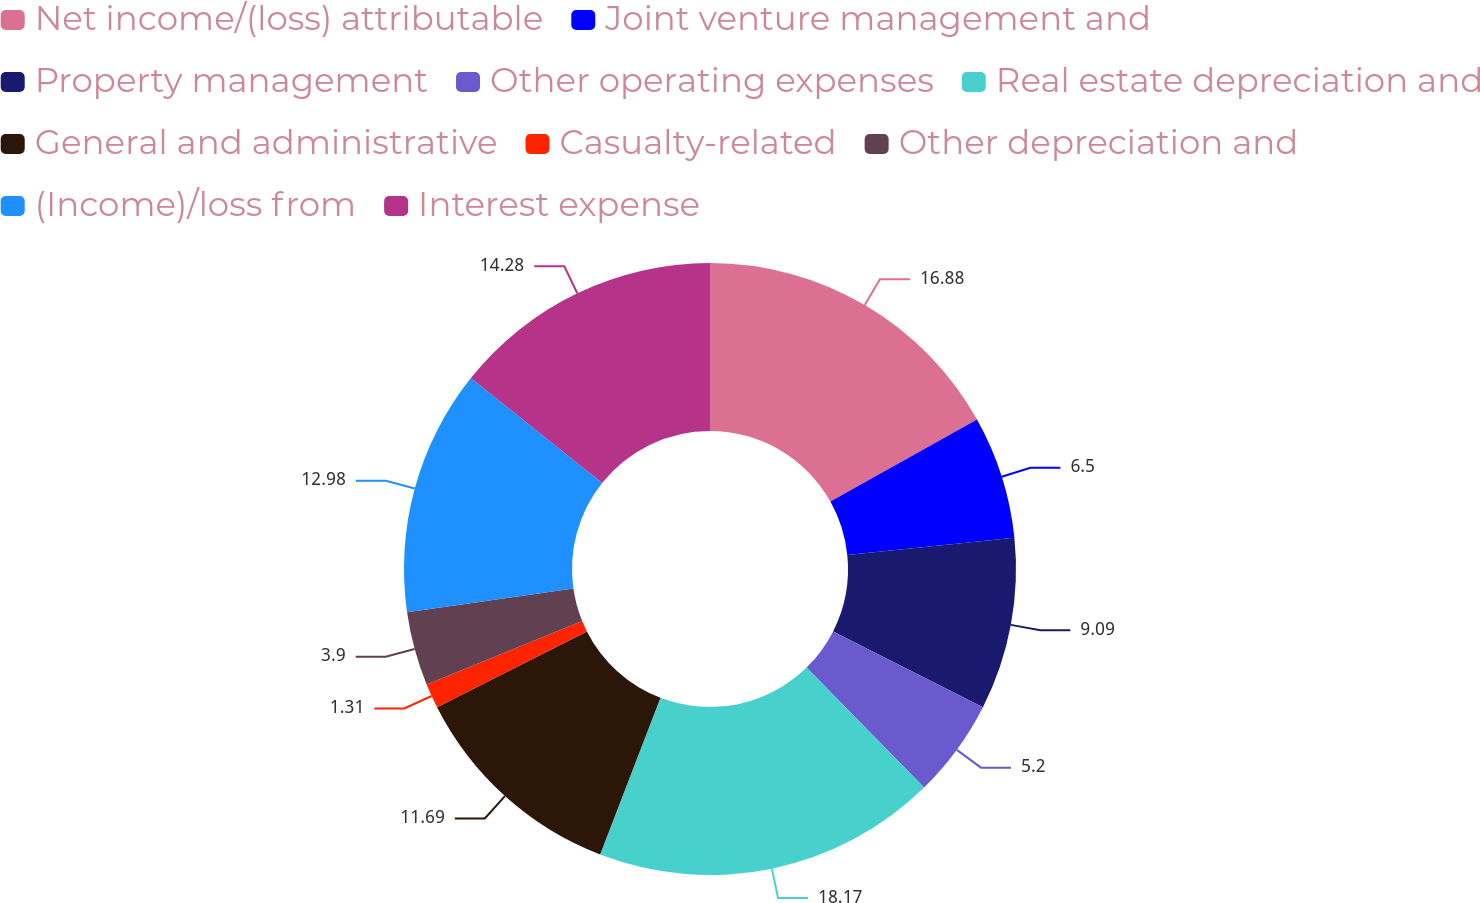Convert chart to OTSL. <chart><loc_0><loc_0><loc_500><loc_500><pie_chart><fcel>Net income/(loss) attributable<fcel>Joint venture management and<fcel>Property management<fcel>Other operating expenses<fcel>Real estate depreciation and<fcel>General and administrative<fcel>Casualty-related<fcel>Other depreciation and<fcel>(Income)/loss from<fcel>Interest expense<nl><fcel>16.88%<fcel>6.5%<fcel>9.09%<fcel>5.2%<fcel>18.18%<fcel>11.69%<fcel>1.31%<fcel>3.9%<fcel>12.98%<fcel>14.28%<nl></chart> 